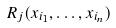Convert formula to latex. <formula><loc_0><loc_0><loc_500><loc_500>R _ { j } ( x _ { i _ { 1 } } , \dots , x _ { i _ { n } } )</formula> 